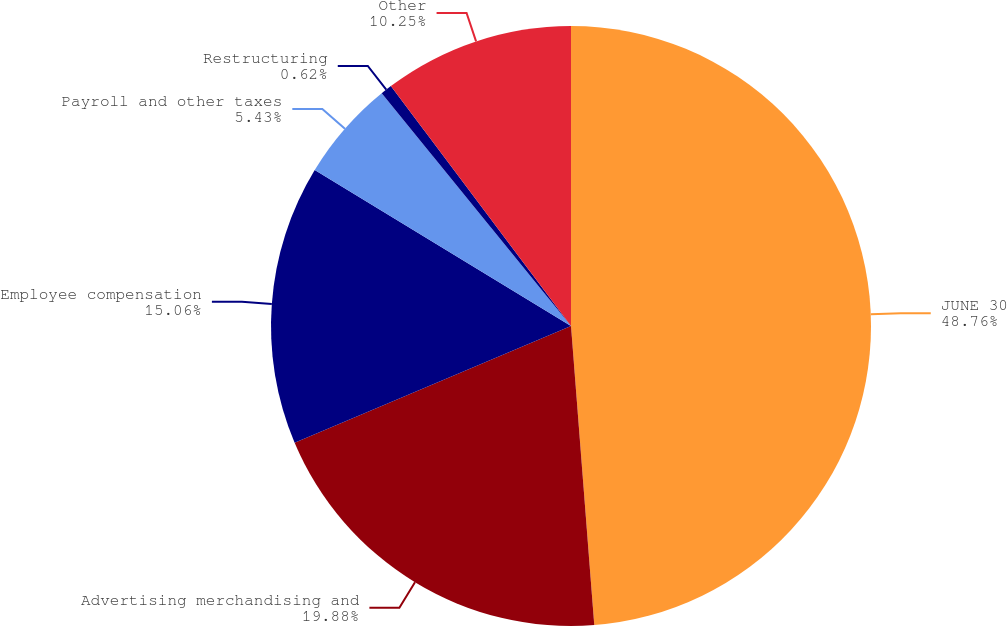Convert chart to OTSL. <chart><loc_0><loc_0><loc_500><loc_500><pie_chart><fcel>JUNE 30<fcel>Advertising merchandising and<fcel>Employee compensation<fcel>Payroll and other taxes<fcel>Restructuring<fcel>Other<nl><fcel>48.77%<fcel>19.88%<fcel>15.06%<fcel>5.43%<fcel>0.62%<fcel>10.25%<nl></chart> 